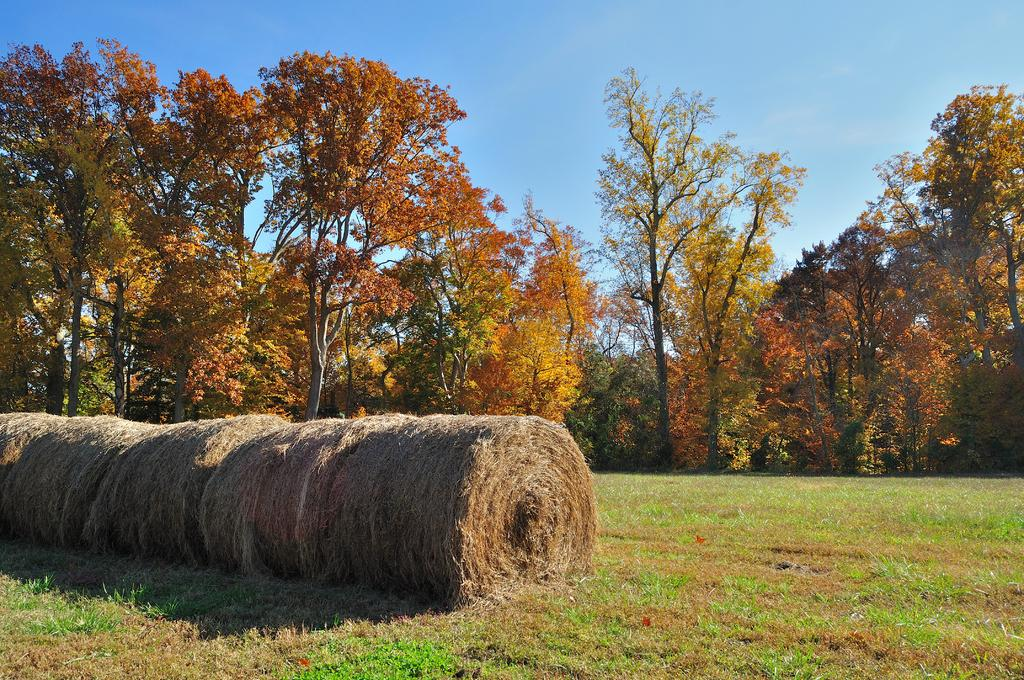What type of vegetation can be seen in the image? There is hay and grass visible in the image. What can be seen in the background of the image? There are trees and the sky visible in the background of the image. What type of quilt is being used to cover the trees in the image? There is no quilt present in the image, and the trees are not covered. Can you see a maid in the image? There is no maid present in the image. 